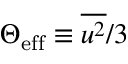Convert formula to latex. <formula><loc_0><loc_0><loc_500><loc_500>\Theta _ { e f f } \equiv \overline { { u ^ { 2 } } } / 3</formula> 